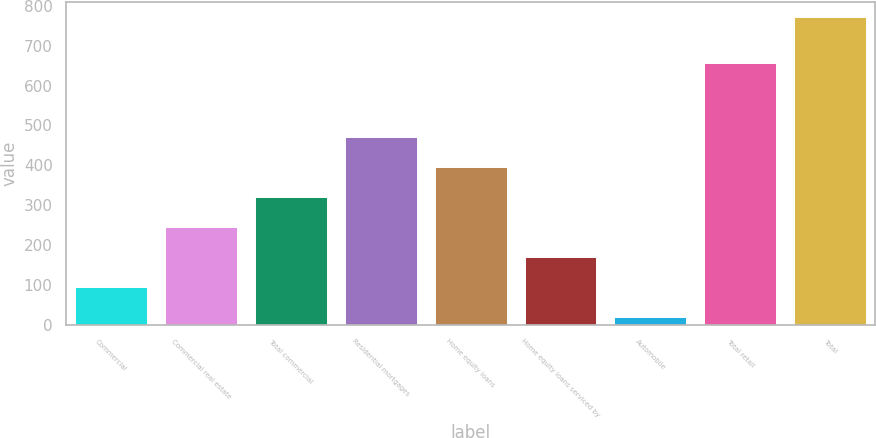Convert chart. <chart><loc_0><loc_0><loc_500><loc_500><bar_chart><fcel>Commercial<fcel>Commercial real estate<fcel>Total commercial<fcel>Residential mortgages<fcel>Home equity loans<fcel>Home equity loans serviced by<fcel>Automobile<fcel>Total retail<fcel>Total<nl><fcel>94.2<fcel>244.6<fcel>319.8<fcel>470.2<fcel>395<fcel>169.4<fcel>19<fcel>656<fcel>771<nl></chart> 